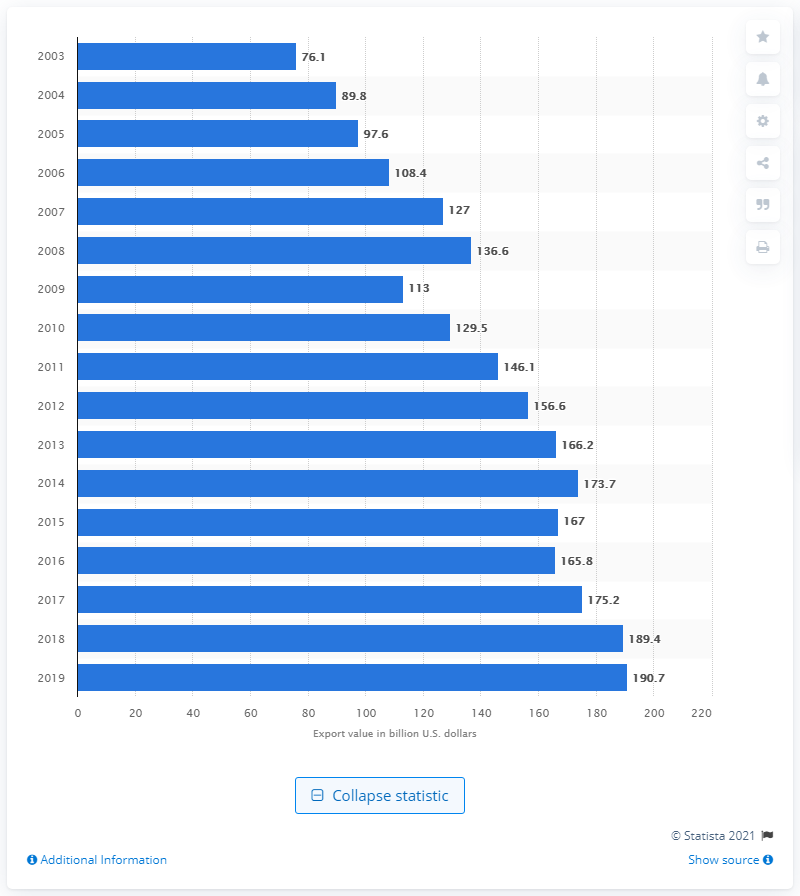Mention a couple of crucial points in this snapshot. In 2003, the export value of furniture was 76.1 million dollars. In 2019, the global export value of furniture was 189.4 billion U.S. dollars. 